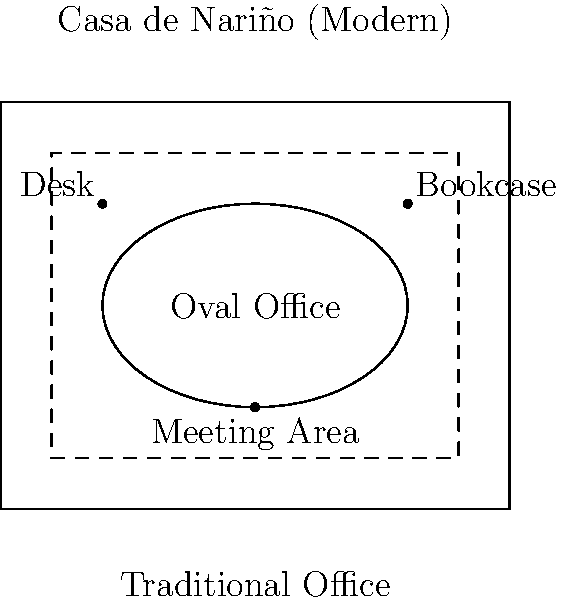Based on the floor plan diagram of the Casa de Nariño (Modern Colombian Presidential Palace), how does the layout of the presidential office differ from traditional Colombian office arrangements, and what historical influence might this suggest? To answer this question, we need to analyze the floor plan diagram and consider the historical context of Colombian presidential traditions:

1. Observe the modern Casa de Nariño layout:
   - It features an oval-shaped office in the center.
   - The oval office is surrounded by a rectangular outer structure.

2. Compare with the traditional Colombian office (dashed lines):
   - The traditional office is typically rectangular.
   - It has a more rigid and formal arrangement.

3. Historical influence:
   - The oval shape is reminiscent of the U.S. White House's Oval Office.
   - This suggests an American influence on the Colombian presidential office design.

4. Consider the nostalgic view on presidential traditions:
   - The traditional rectangular office represents Colombia's historical approach.
   - The adoption of an oval office indicates a departure from this tradition.

5. Analyze the implications:
   - The oval shape allows for a more dynamic and less hierarchical arrangement of furniture.
   - It symbolizes a more modern and potentially more accessible presidency.

6. Conclusion:
   The layout differs significantly from traditional Colombian offices by incorporating an oval design, suggesting a strong American influence and a shift away from Colombia's historical presidential traditions.
Answer: Oval design influenced by U.S., departing from traditional rectangular layout 